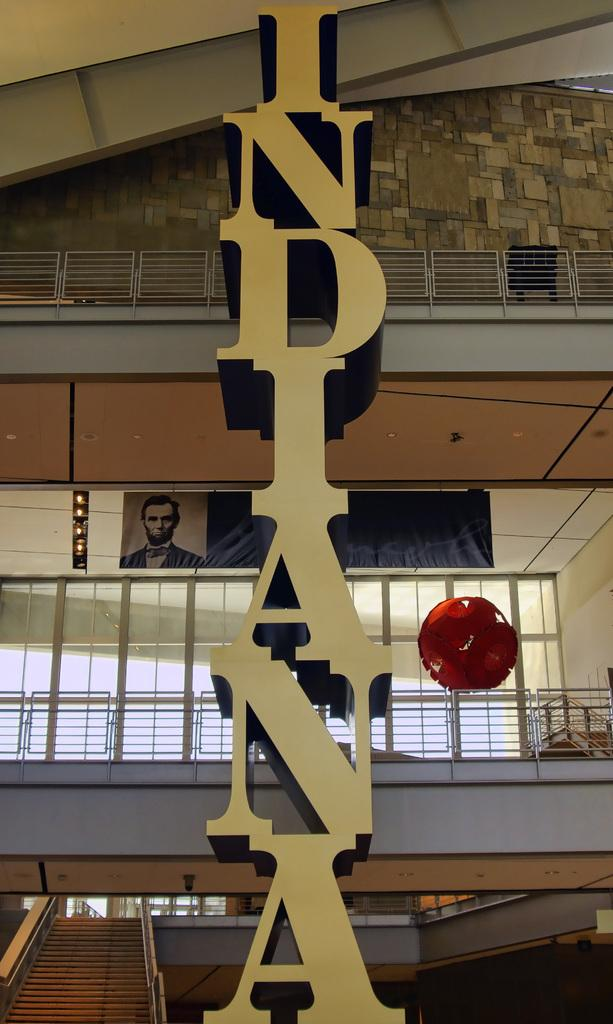What is the main subject in the center of the image? There is a hoarding in the center of the image. What can be seen in the background of the image? In the background of the image, there are railings, banners, a staircase, and glass windows. How much money is being exchanged in the image? There is no indication of money being exchanged in the image. What type of voyage is being depicted in the image? There is no voyage depicted in the image; it features a hoarding and various background elements. 